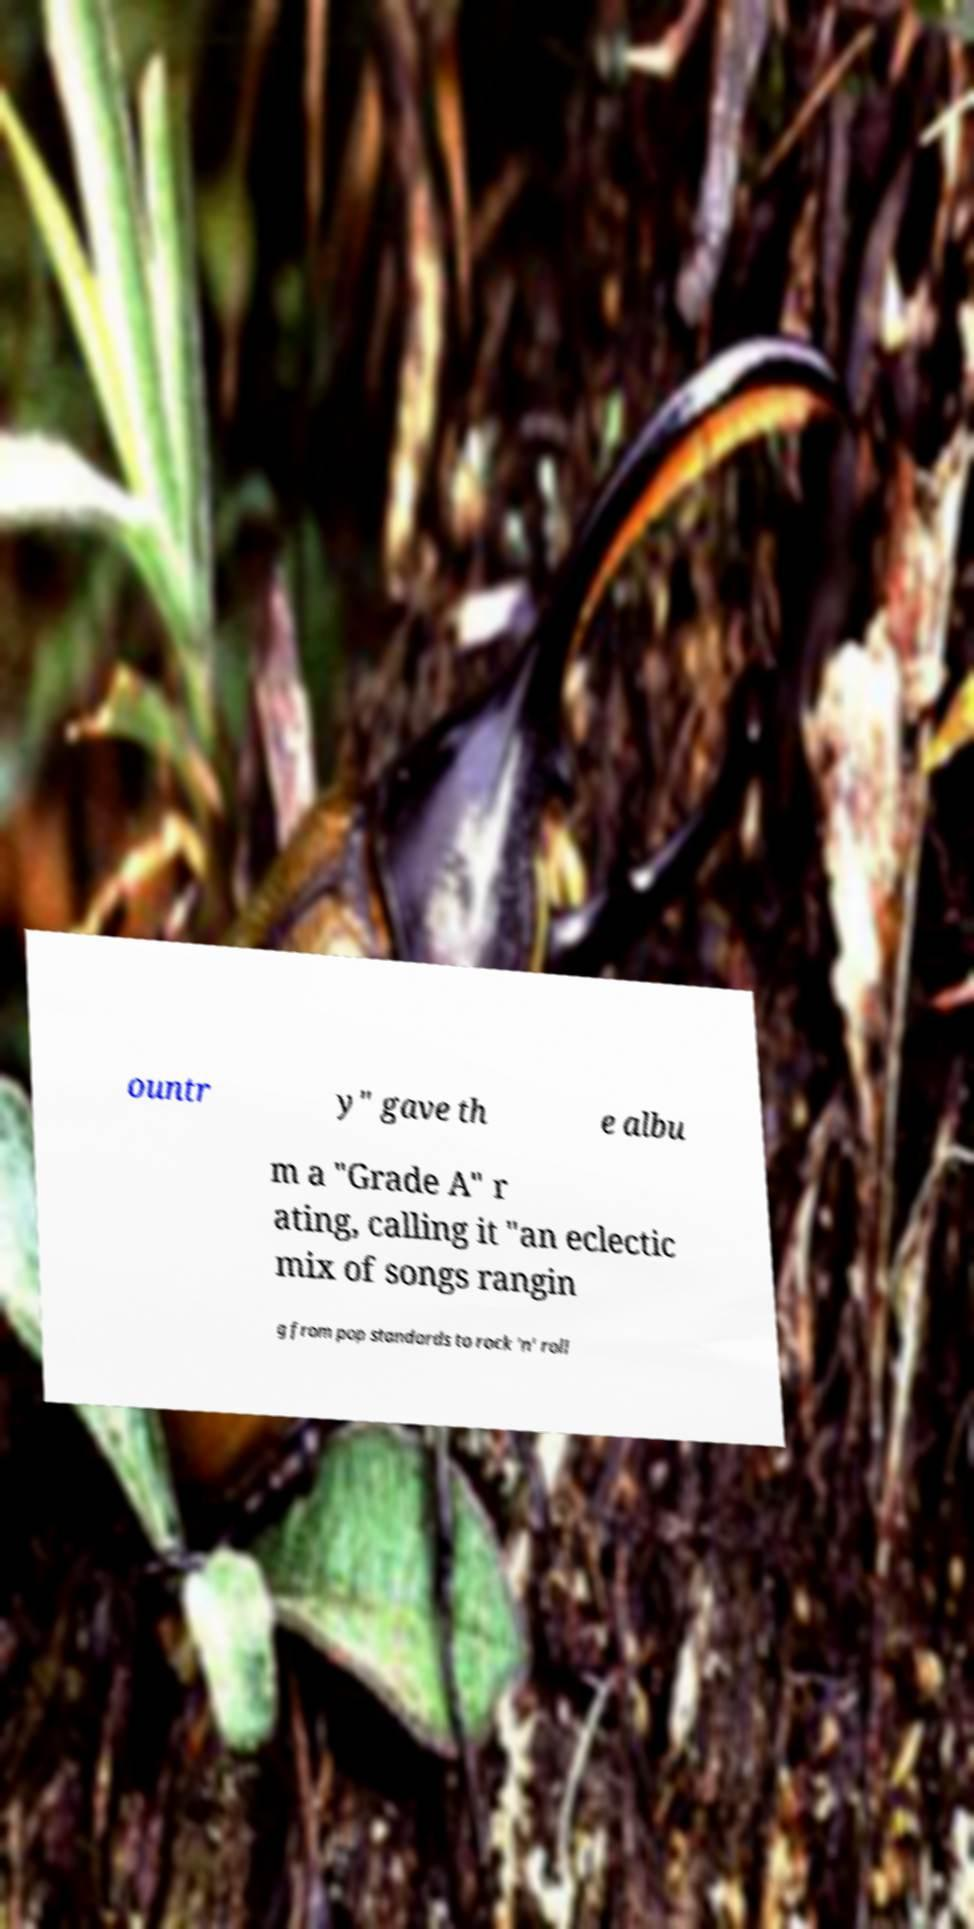For documentation purposes, I need the text within this image transcribed. Could you provide that? ountr y" gave th e albu m a "Grade A" r ating, calling it "an eclectic mix of songs rangin g from pop standards to rock 'n' roll 